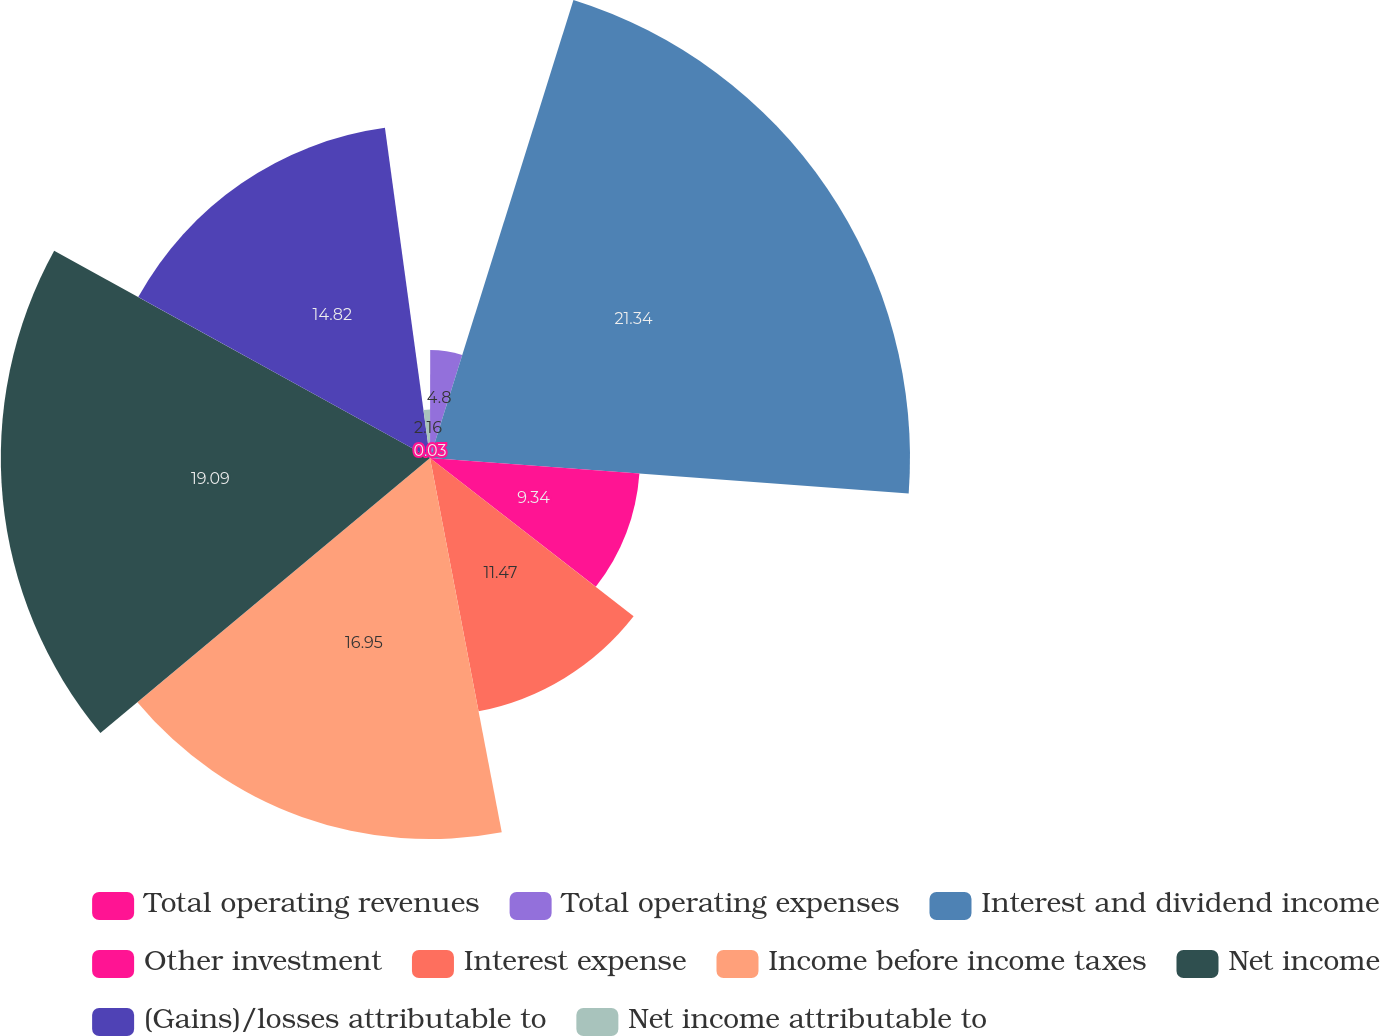Convert chart. <chart><loc_0><loc_0><loc_500><loc_500><pie_chart><fcel>Total operating revenues<fcel>Total operating expenses<fcel>Interest and dividend income<fcel>Other investment<fcel>Interest expense<fcel>Income before income taxes<fcel>Net income<fcel>(Gains)/losses attributable to<fcel>Net income attributable to<nl><fcel>0.03%<fcel>4.8%<fcel>21.35%<fcel>9.34%<fcel>11.47%<fcel>16.95%<fcel>19.09%<fcel>14.82%<fcel>2.16%<nl></chart> 